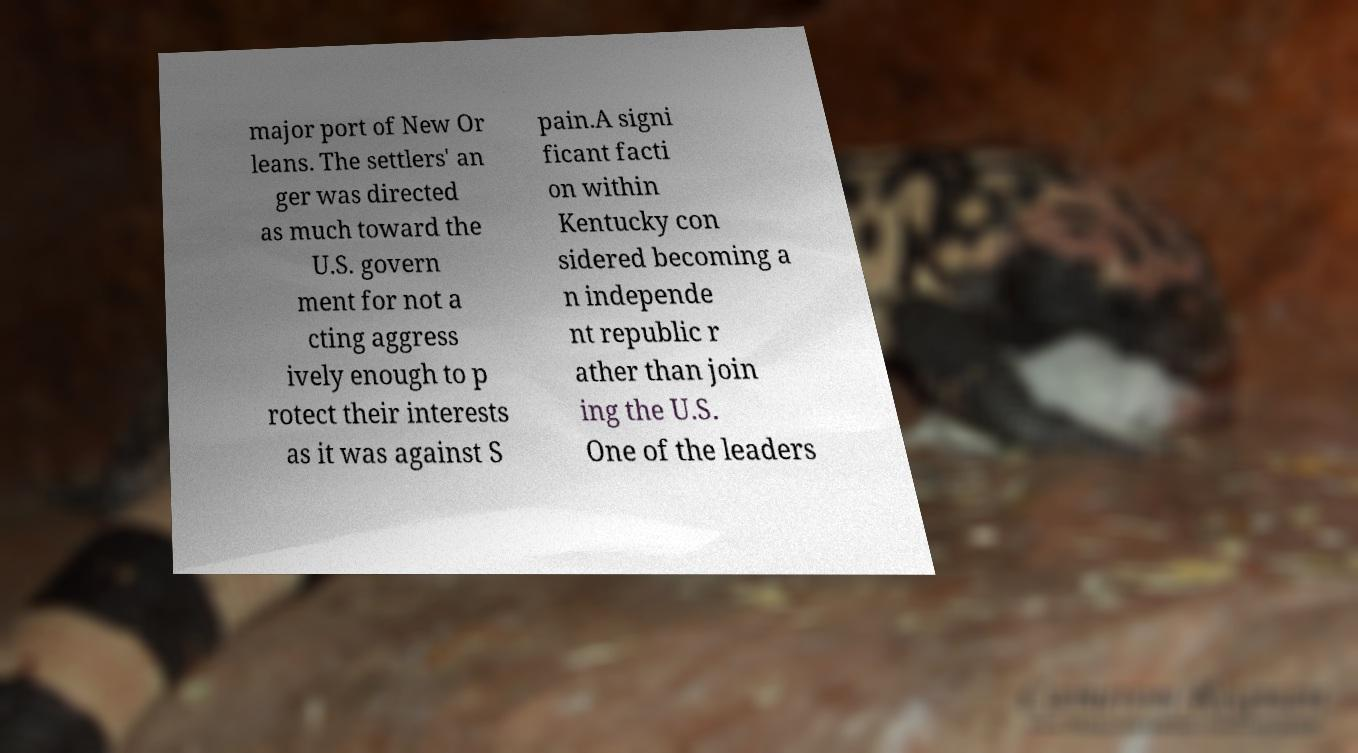I need the written content from this picture converted into text. Can you do that? major port of New Or leans. The settlers' an ger was directed as much toward the U.S. govern ment for not a cting aggress ively enough to p rotect their interests as it was against S pain.A signi ficant facti on within Kentucky con sidered becoming a n independe nt republic r ather than join ing the U.S. One of the leaders 